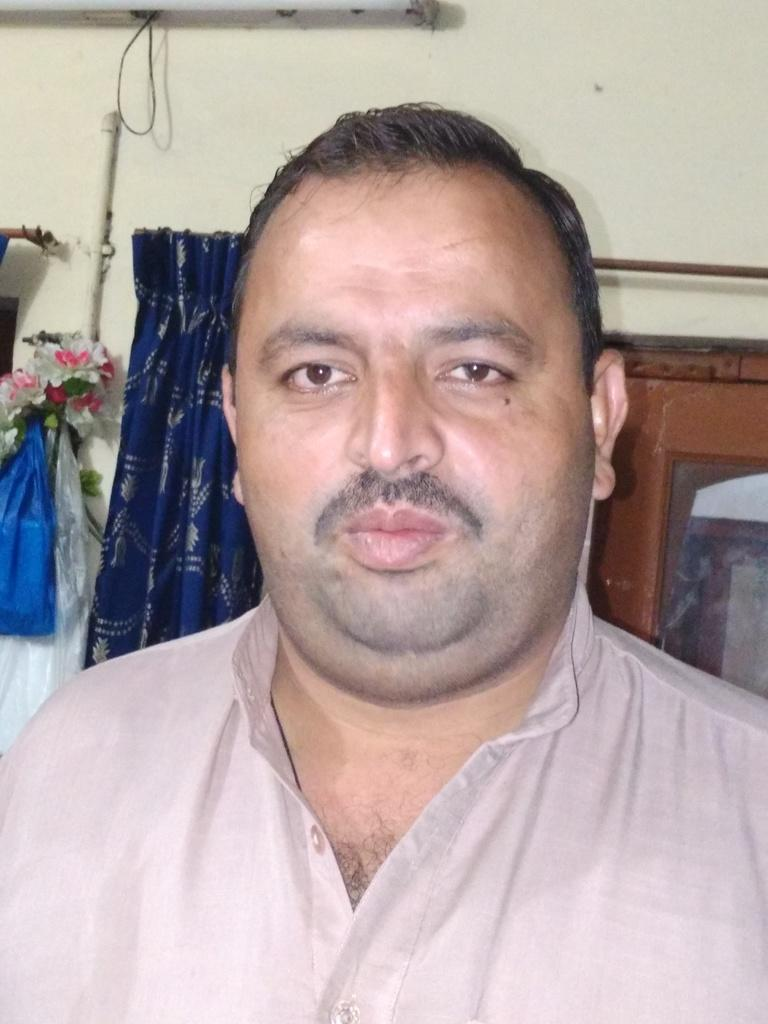Who is the main subject in the image? There is a man in the middle of the image. What is located behind the man? There are plastic covers behind the man. Can you describe any objects related to plants in the image? There is a flower vase in the image. What type of window treatment is present in the image? There are curtains in the image. Where is the light source located in the image? There is a light on the wall in the image. How many snails are crawling on the man's shoulder in the image? There are no snails present in the image; the man's shoulder is not visible. 